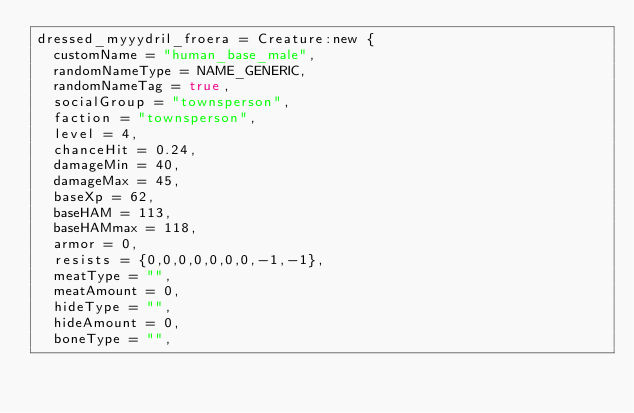<code> <loc_0><loc_0><loc_500><loc_500><_Lua_>dressed_myyydril_froera = Creature:new {
	customName = "human_base_male",
	randomNameType = NAME_GENERIC,
	randomNameTag = true,
	socialGroup = "townsperson",
	faction = "townsperson",
	level = 4,
	chanceHit = 0.24,
	damageMin = 40,
	damageMax = 45,
	baseXp = 62,
	baseHAM = 113,
	baseHAMmax = 118,
	armor = 0,
	resists = {0,0,0,0,0,0,0,-1,-1},
	meatType = "",
	meatAmount = 0,
	hideType = "",
	hideAmount = 0,
	boneType = "",</code> 